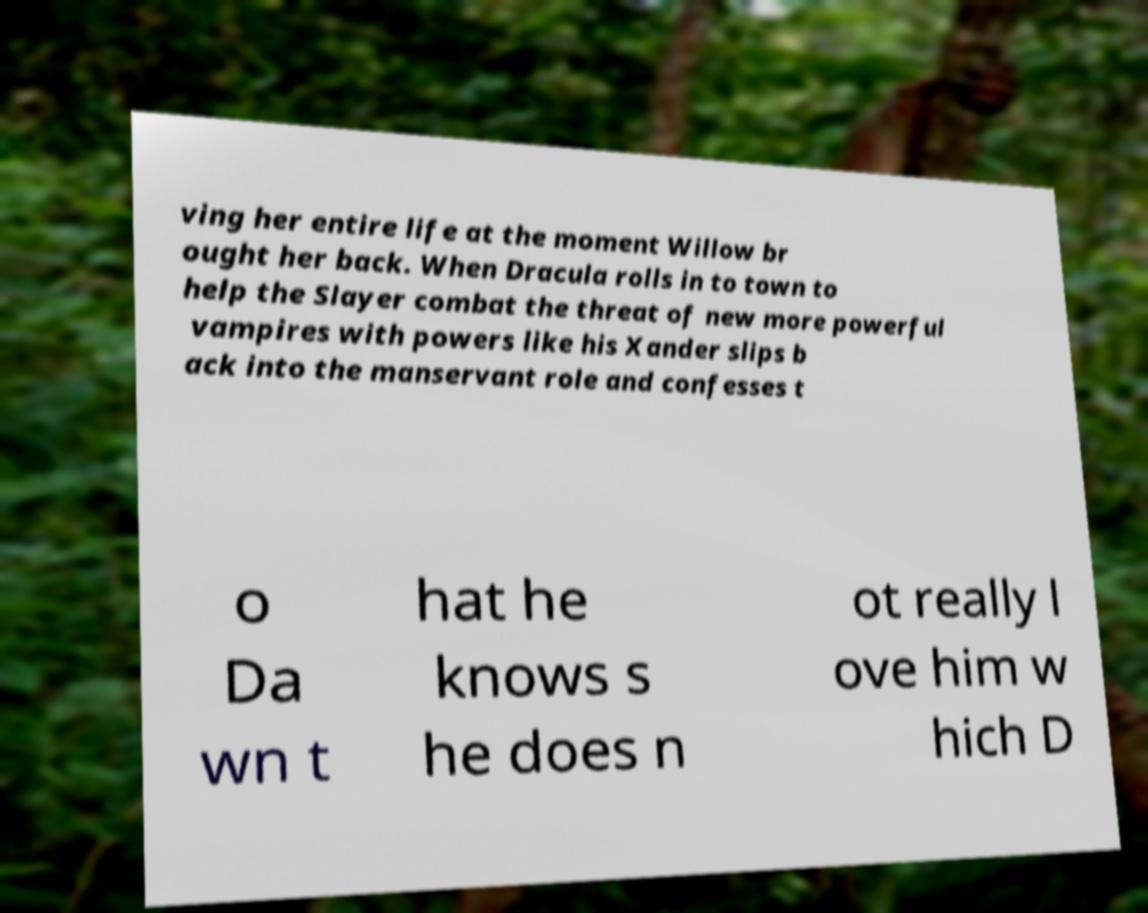Could you extract and type out the text from this image? ving her entire life at the moment Willow br ought her back. When Dracula rolls in to town to help the Slayer combat the threat of new more powerful vampires with powers like his Xander slips b ack into the manservant role and confesses t o Da wn t hat he knows s he does n ot really l ove him w hich D 